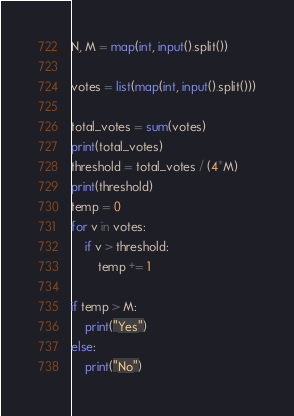<code> <loc_0><loc_0><loc_500><loc_500><_Python_>N, M = map(int, input().split())

votes = list(map(int, input().split()))

total_votes = sum(votes)
print(total_votes)
threshold = total_votes / (4*M)
print(threshold)
temp = 0
for v in votes:
    if v > threshold:
        temp += 1

if temp > M:
    print("Yes")
else:
    print("No")
</code> 